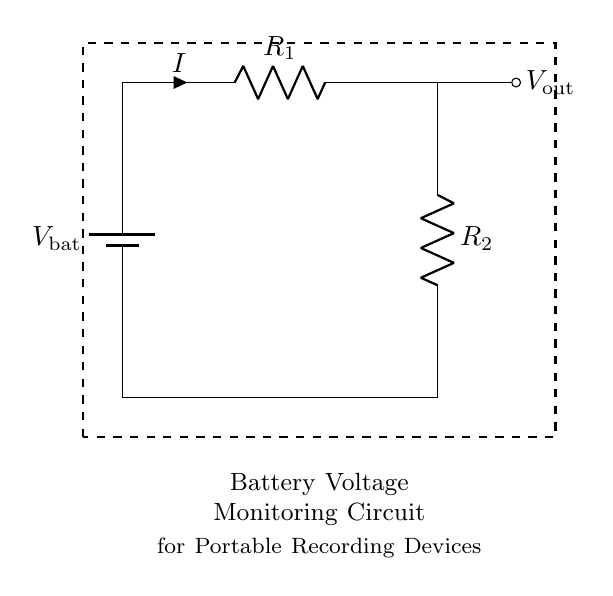What type of components are used in this circuit? The circuit uses a battery and two resistors, which are essential for the voltage divider function.
Answer: battery and resistors What is the purpose of R1 in this circuit? R1 is part of the voltage divider, helping to determine the output voltage based on its resistance relative to R2.
Answer: voltage divider function What is the output voltage denoted as in the circuit? The output voltage is expected to be measured across R2, marked as Vout in the circuit.
Answer: Vout How many resistors are present in this circuit? There are two resistors in the circuit, R1 and R2, which are necessary for dividing the voltage.
Answer: two What is the relationship between the resistors and output voltage in a voltage divider? The output voltage is proportionate to the ratio of R2 to the total resistance (R1 + R2), which affects how the voltage is distributed.
Answer: ratio of resistors What would happen to Vout if R2 is made larger than R1? Making R2 larger would increase Vout because a greater portion of the input voltage would drop across R2; hence, Vout would rise.
Answer: increase Vout 